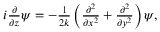Convert formula to latex. <formula><loc_0><loc_0><loc_500><loc_500>\begin{array} { r } { i \frac { \partial } { \partial z } \psi = - \frac { 1 } { 2 k } \left ( \frac { \partial ^ { 2 } } { \partial x ^ { 2 } } + \frac { \partial ^ { 2 } } { \partial y ^ { 2 } } \right ) \psi , } \end{array}</formula> 